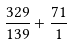Convert formula to latex. <formula><loc_0><loc_0><loc_500><loc_500>\frac { 3 2 9 } { 1 3 9 } + \frac { 7 1 } { 1 }</formula> 